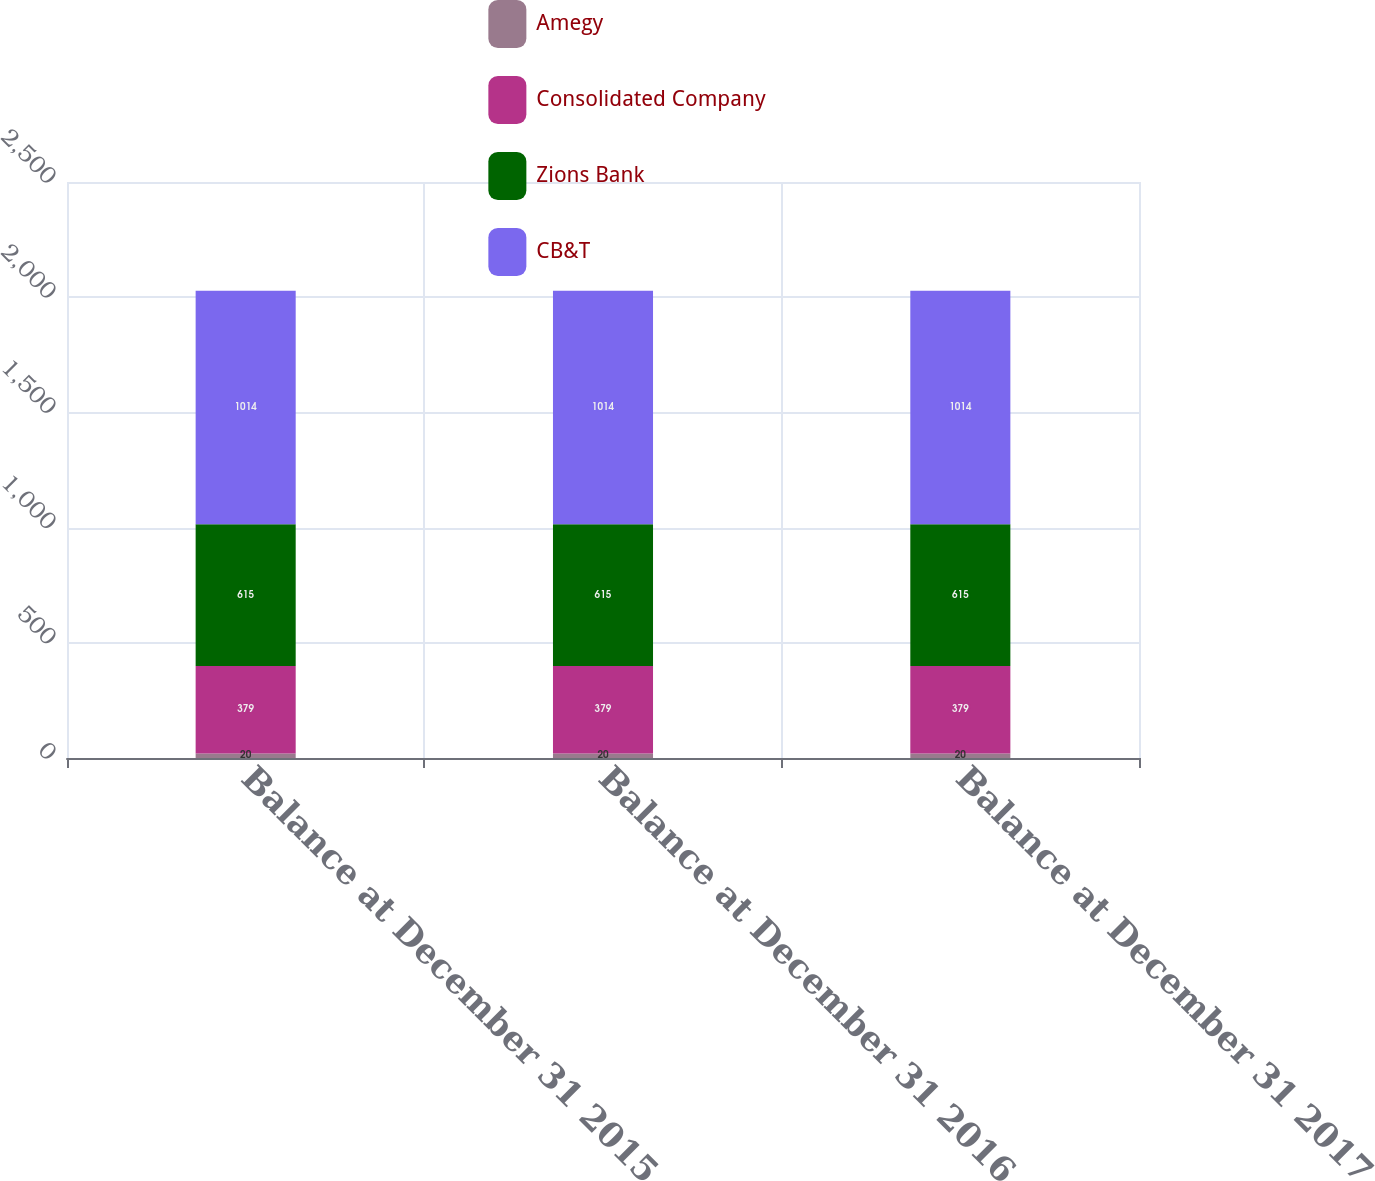<chart> <loc_0><loc_0><loc_500><loc_500><stacked_bar_chart><ecel><fcel>Balance at December 31 2015<fcel>Balance at December 31 2016<fcel>Balance at December 31 2017<nl><fcel>Amegy<fcel>20<fcel>20<fcel>20<nl><fcel>Consolidated Company<fcel>379<fcel>379<fcel>379<nl><fcel>Zions Bank<fcel>615<fcel>615<fcel>615<nl><fcel>CB&T<fcel>1014<fcel>1014<fcel>1014<nl></chart> 